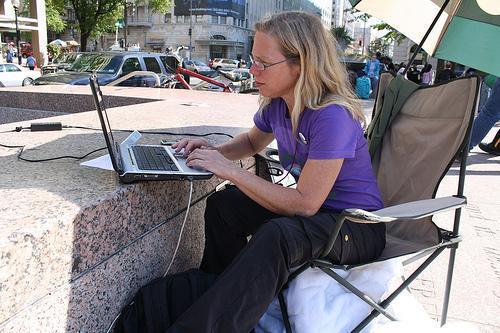How many people are typing?
Give a very brief answer. 1. 